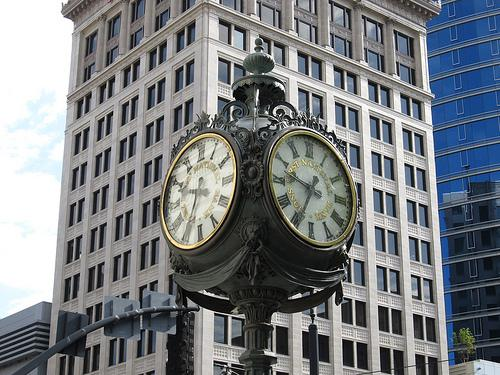Question: when is this?
Choices:
A. Afternoon.
B. Morning.
C. Easter.
D. Fourth of July.
Answer with the letter. Answer: A Question: what is in the background?
Choices:
A. Building.
B. Dog.
C. House.
D. Chapel.
Answer with the letter. Answer: A Question: where is this scene?
Choices:
A. Beach.
B. Hotel.
C. Vegas.
D. Outside a building.
Answer with the letter. Answer: D Question: what is all over the building?
Choices:
A. Door.
B. Dirt.
C. Windows.
D. Birds.
Answer with the letter. Answer: C 